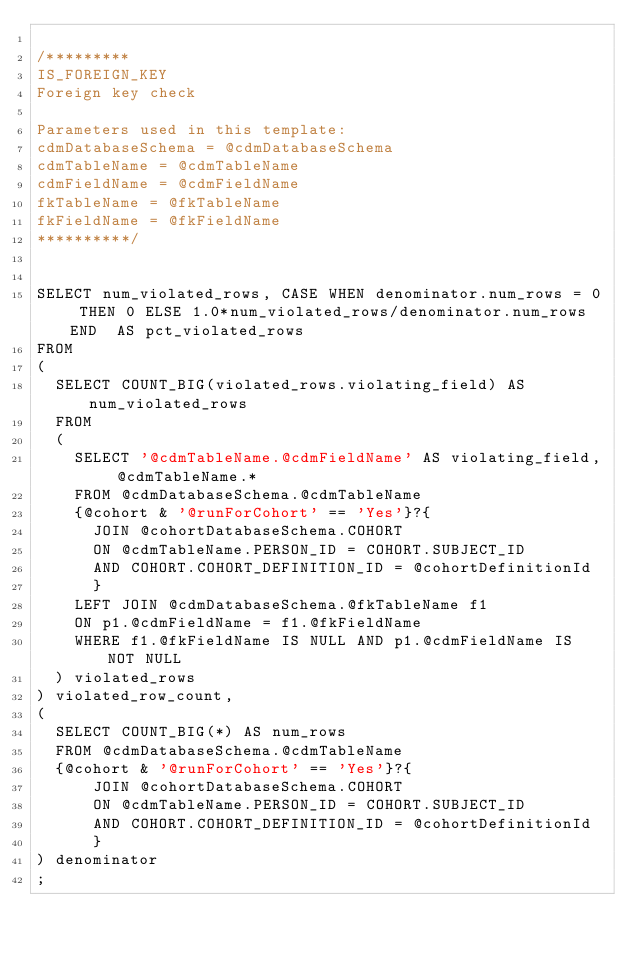Convert code to text. <code><loc_0><loc_0><loc_500><loc_500><_SQL_>
/*********
IS_FOREIGN_KEY
Foreign key check

Parameters used in this template:
cdmDatabaseSchema = @cdmDatabaseSchema
cdmTableName = @cdmTableName
cdmFieldName = @cdmFieldName
fkTableName = @fkTableName
fkFieldName = @fkFieldName
**********/


SELECT num_violated_rows, CASE WHEN denominator.num_rows = 0 THEN 0 ELSE 1.0*num_violated_rows/denominator.num_rows END  AS pct_violated_rows
FROM
(
	SELECT COUNT_BIG(violated_rows.violating_field) AS num_violated_rows
	FROM
	(
		SELECT '@cdmTableName.@cdmFieldName' AS violating_field, @cdmTableName.* 
		FROM @cdmDatabaseSchema.@cdmTableName 
		{@cohort & '@runForCohort' == 'Yes'}?{
    	JOIN @cohortDatabaseSchema.COHORT 
    	ON @cdmTableName.PERSON_ID = COHORT.SUBJECT_ID
    	AND COHORT.COHORT_DEFINITION_ID = @cohortDefinitionId
    	}
		LEFT JOIN @cdmDatabaseSchema.@fkTableName f1
		ON p1.@cdmFieldName = f1.@fkFieldName
		WHERE f1.@fkFieldName IS NULL AND p1.@cdmFieldName IS NOT NULL 
	) violated_rows
) violated_row_count,
( 
	SELECT COUNT_BIG(*) AS num_rows
	FROM @cdmDatabaseSchema.@cdmTableName
	{@cohort & '@runForCohort' == 'Yes'}?{
    	JOIN @cohortDatabaseSchema.COHORT 
    	ON @cdmTableName.PERSON_ID = COHORT.SUBJECT_ID
    	AND COHORT.COHORT_DEFINITION_ID = @cohortDefinitionId
    	}
) denominator
;</code> 